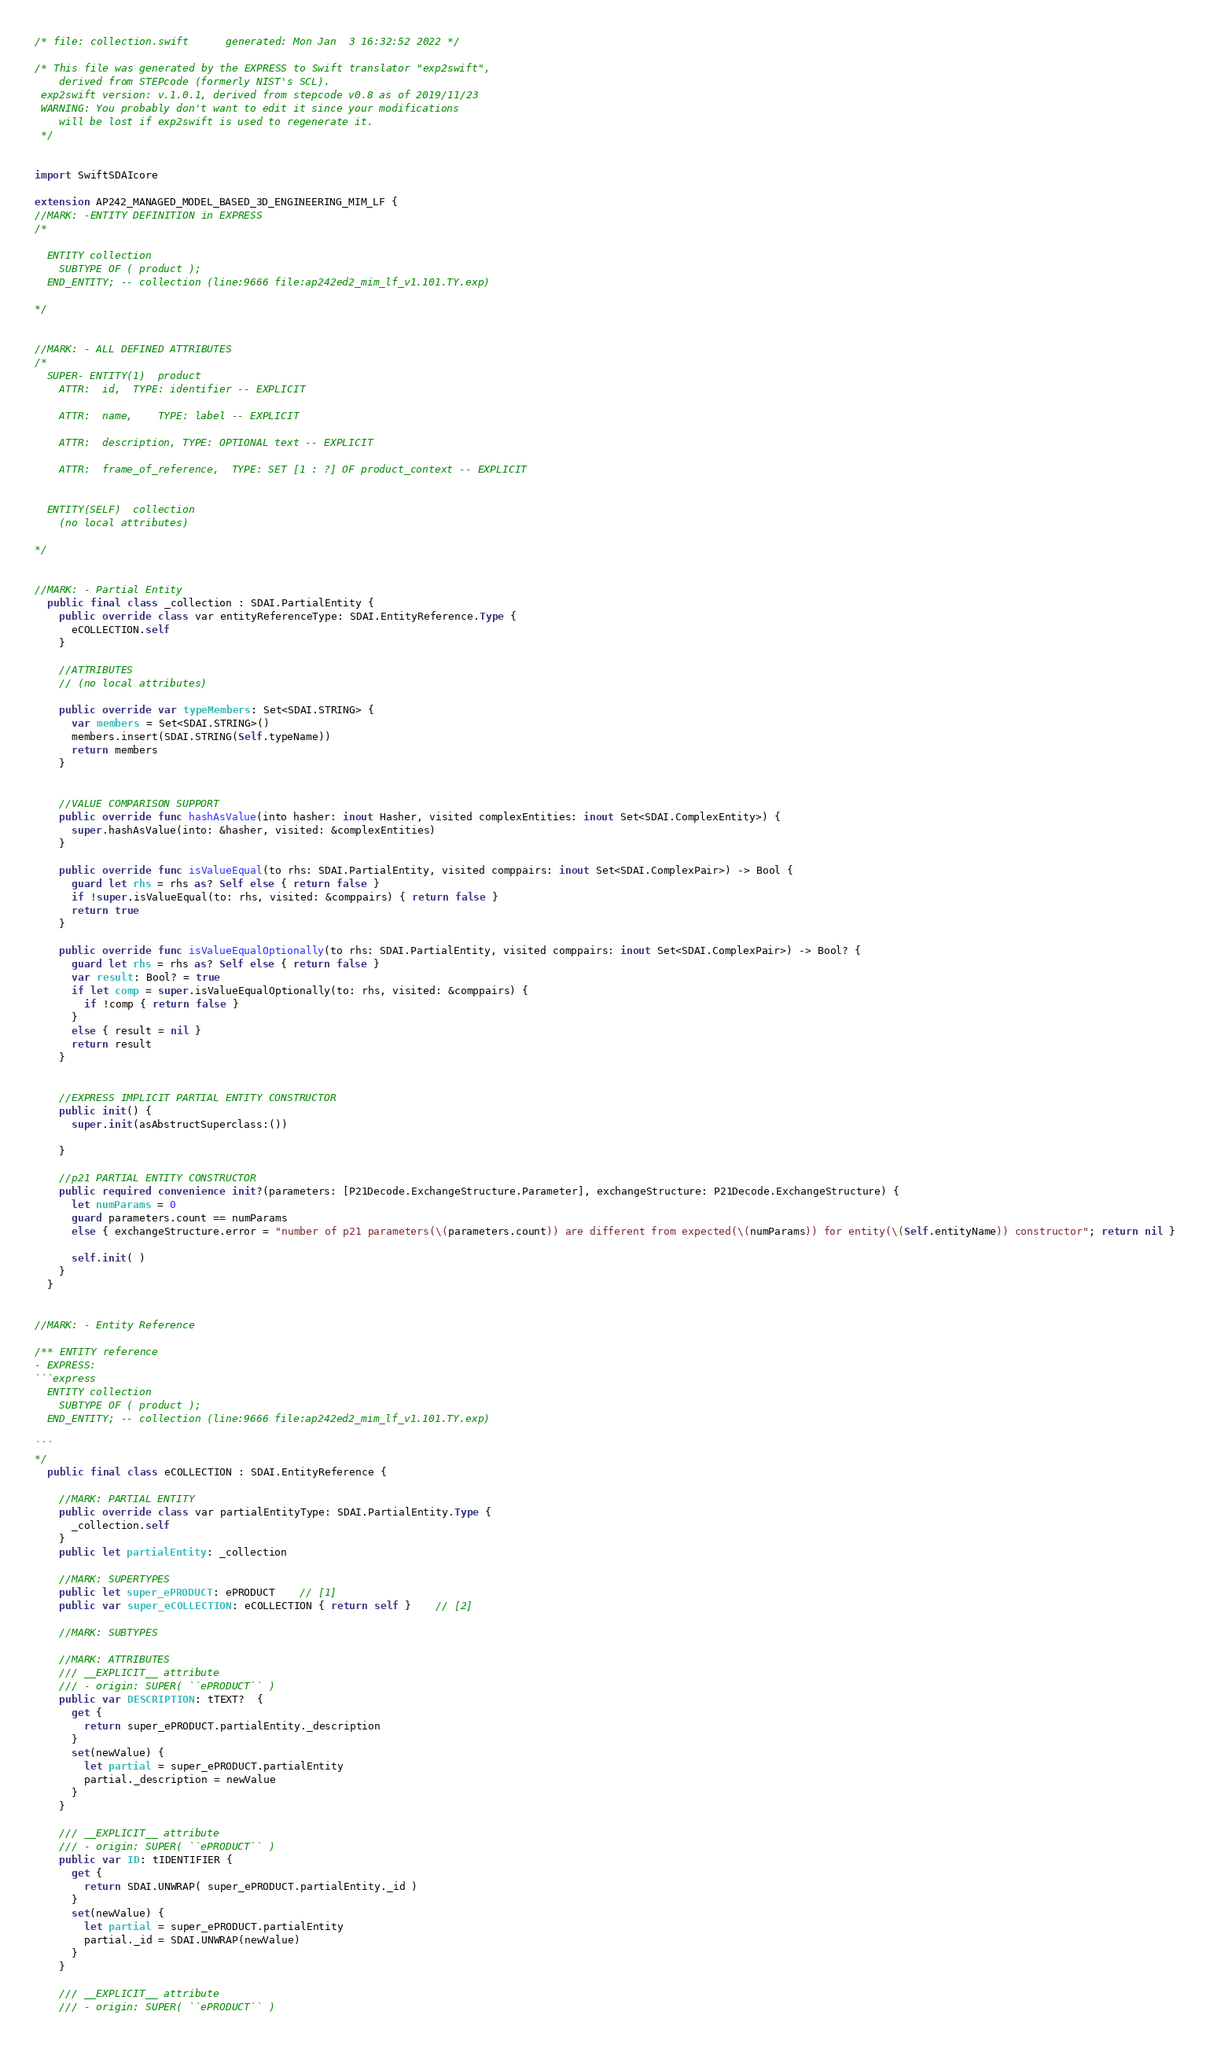<code> <loc_0><loc_0><loc_500><loc_500><_Swift_>/* file: collection.swift 	 generated: Mon Jan  3 16:32:52 2022 */

/* This file was generated by the EXPRESS to Swift translator "exp2swift", 
    derived from STEPcode (formerly NIST's SCL).
 exp2swift version: v.1.0.1, derived from stepcode v0.8 as of 2019/11/23 
 WARNING: You probably don't want to edit it since your modifications 
    will be lost if exp2swift is used to regenerate it.
 */

 
import SwiftSDAIcore

extension AP242_MANAGED_MODEL_BASED_3D_ENGINEERING_MIM_LF {
//MARK: -ENTITY DEFINITION in EXPRESS
/*

  ENTITY collection
    SUBTYPE OF ( product );
  END_ENTITY; -- collection (line:9666 file:ap242ed2_mim_lf_v1.101.TY.exp)

*/


//MARK: - ALL DEFINED ATTRIBUTES
/*
  SUPER- ENTITY(1)	product
    ATTR:  id,	TYPE: identifier -- EXPLICIT

    ATTR:  name,	TYPE: label -- EXPLICIT

    ATTR:  description,	TYPE: OPTIONAL text -- EXPLICIT

    ATTR:  frame_of_reference,	TYPE: SET [1 : ?] OF product_context -- EXPLICIT


  ENTITY(SELF)	collection
    (no local attributes)

*/


//MARK: - Partial Entity
  public final class _collection : SDAI.PartialEntity {
    public override class var entityReferenceType: SDAI.EntityReference.Type {
      eCOLLECTION.self
    }

    //ATTRIBUTES
    // (no local attributes)

    public override var typeMembers: Set<SDAI.STRING> {
      var members = Set<SDAI.STRING>()
      members.insert(SDAI.STRING(Self.typeName))
      return members
    }


    //VALUE COMPARISON SUPPORT
    public override func hashAsValue(into hasher: inout Hasher, visited complexEntities: inout Set<SDAI.ComplexEntity>) {
      super.hashAsValue(into: &hasher, visited: &complexEntities)
    }

    public override func isValueEqual(to rhs: SDAI.PartialEntity, visited comppairs: inout Set<SDAI.ComplexPair>) -> Bool {
      guard let rhs = rhs as? Self else { return false }
      if !super.isValueEqual(to: rhs, visited: &comppairs) { return false }
      return true
    }

    public override func isValueEqualOptionally(to rhs: SDAI.PartialEntity, visited comppairs: inout Set<SDAI.ComplexPair>) -> Bool? {
      guard let rhs = rhs as? Self else { return false }
      var result: Bool? = true
      if let comp = super.isValueEqualOptionally(to: rhs, visited: &comppairs) {
        if !comp { return false }
      }
      else { result = nil }
      return result
    }


    //EXPRESS IMPLICIT PARTIAL ENTITY CONSTRUCTOR
    public init() {
      super.init(asAbstructSuperclass:())

    }

    //p21 PARTIAL ENTITY CONSTRUCTOR
    public required convenience init?(parameters: [P21Decode.ExchangeStructure.Parameter], exchangeStructure: P21Decode.ExchangeStructure) {
      let numParams = 0
      guard parameters.count == numParams
      else { exchangeStructure.error = "number of p21 parameters(\(parameters.count)) are different from expected(\(numParams)) for entity(\(Self.entityName)) constructor"; return nil }

      self.init( )
    }
  }


//MARK: - Entity Reference

/** ENTITY reference
- EXPRESS:
```express
  ENTITY collection
    SUBTYPE OF ( product );
  END_ENTITY; -- collection (line:9666 file:ap242ed2_mim_lf_v1.101.TY.exp)

```
*/
  public final class eCOLLECTION : SDAI.EntityReference {

    //MARK: PARTIAL ENTITY
    public override class var partialEntityType: SDAI.PartialEntity.Type {
      _collection.self
    }
    public let partialEntity: _collection

    //MARK: SUPERTYPES
    public let super_ePRODUCT: ePRODUCT 	// [1]
    public var super_eCOLLECTION: eCOLLECTION { return self } 	// [2]

    //MARK: SUBTYPES

    //MARK: ATTRIBUTES
    /// __EXPLICIT__ attribute
    /// - origin: SUPER( ``ePRODUCT`` )
    public var DESCRIPTION: tTEXT?  {
      get {
        return super_ePRODUCT.partialEntity._description
      }
      set(newValue) {
        let partial = super_ePRODUCT.partialEntity
        partial._description = newValue
      }
    }

    /// __EXPLICIT__ attribute
    /// - origin: SUPER( ``ePRODUCT`` )
    public var ID: tIDENTIFIER {
      get {
        return SDAI.UNWRAP( super_ePRODUCT.partialEntity._id )
      }
      set(newValue) {
        let partial = super_ePRODUCT.partialEntity
        partial._id = SDAI.UNWRAP(newValue)
      }
    }

    /// __EXPLICIT__ attribute
    /// - origin: SUPER( ``ePRODUCT`` )</code> 